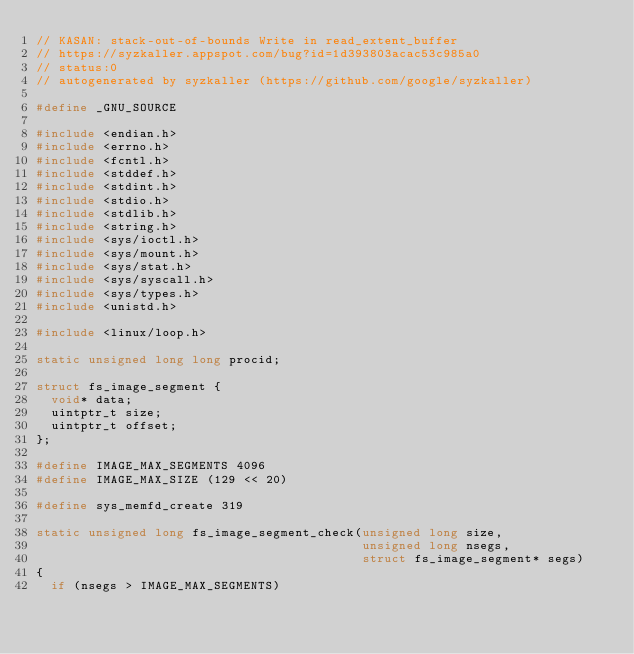<code> <loc_0><loc_0><loc_500><loc_500><_C_>// KASAN: stack-out-of-bounds Write in read_extent_buffer
// https://syzkaller.appspot.com/bug?id=1d393803acac53c985a0
// status:0
// autogenerated by syzkaller (https://github.com/google/syzkaller)

#define _GNU_SOURCE

#include <endian.h>
#include <errno.h>
#include <fcntl.h>
#include <stddef.h>
#include <stdint.h>
#include <stdio.h>
#include <stdlib.h>
#include <string.h>
#include <sys/ioctl.h>
#include <sys/mount.h>
#include <sys/stat.h>
#include <sys/syscall.h>
#include <sys/types.h>
#include <unistd.h>

#include <linux/loop.h>

static unsigned long long procid;

struct fs_image_segment {
  void* data;
  uintptr_t size;
  uintptr_t offset;
};

#define IMAGE_MAX_SEGMENTS 4096
#define IMAGE_MAX_SIZE (129 << 20)

#define sys_memfd_create 319

static unsigned long fs_image_segment_check(unsigned long size,
                                            unsigned long nsegs,
                                            struct fs_image_segment* segs)
{
  if (nsegs > IMAGE_MAX_SEGMENTS)</code> 